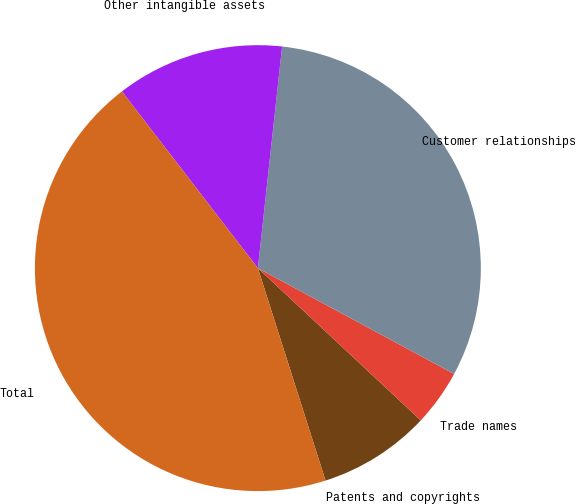Convert chart to OTSL. <chart><loc_0><loc_0><loc_500><loc_500><pie_chart><fcel>Patents and copyrights<fcel>Trade names<fcel>Customer relationships<fcel>Other intangible assets<fcel>Total<nl><fcel>8.13%<fcel>4.09%<fcel>31.14%<fcel>12.17%<fcel>44.47%<nl></chart> 